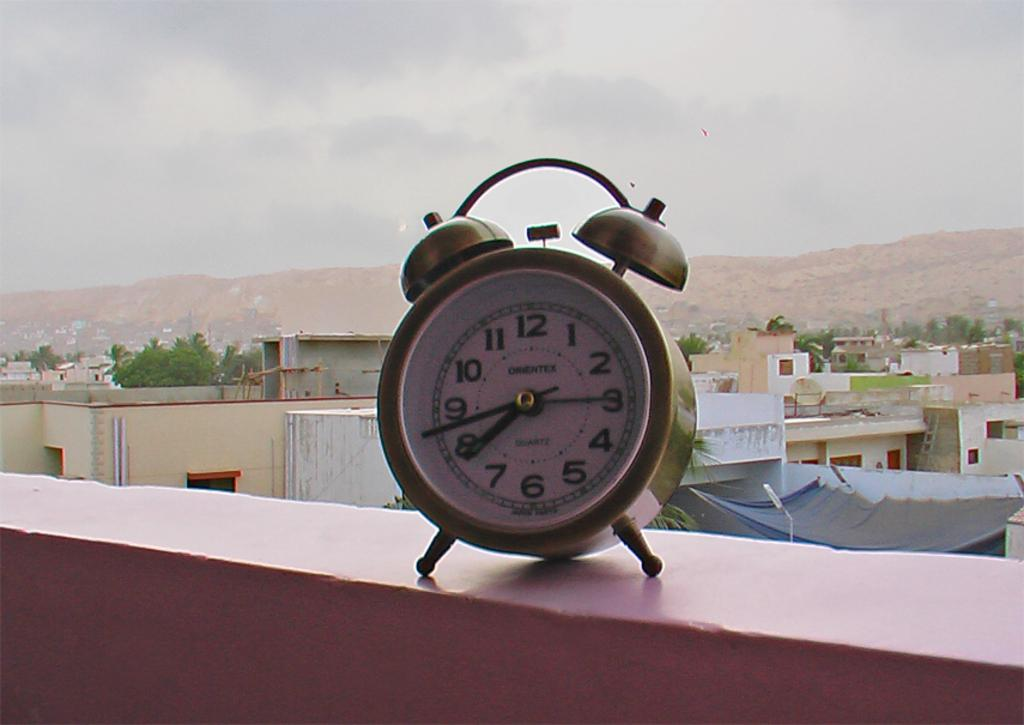<image>
Render a clear and concise summary of the photo. A clock sits on the wall and reads 8:43 